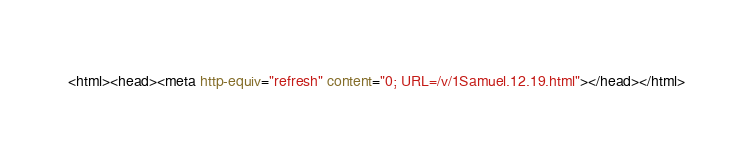Convert code to text. <code><loc_0><loc_0><loc_500><loc_500><_HTML_><html><head><meta http-equiv="refresh" content="0; URL=/v/1Samuel.12.19.html"></head></html></code> 